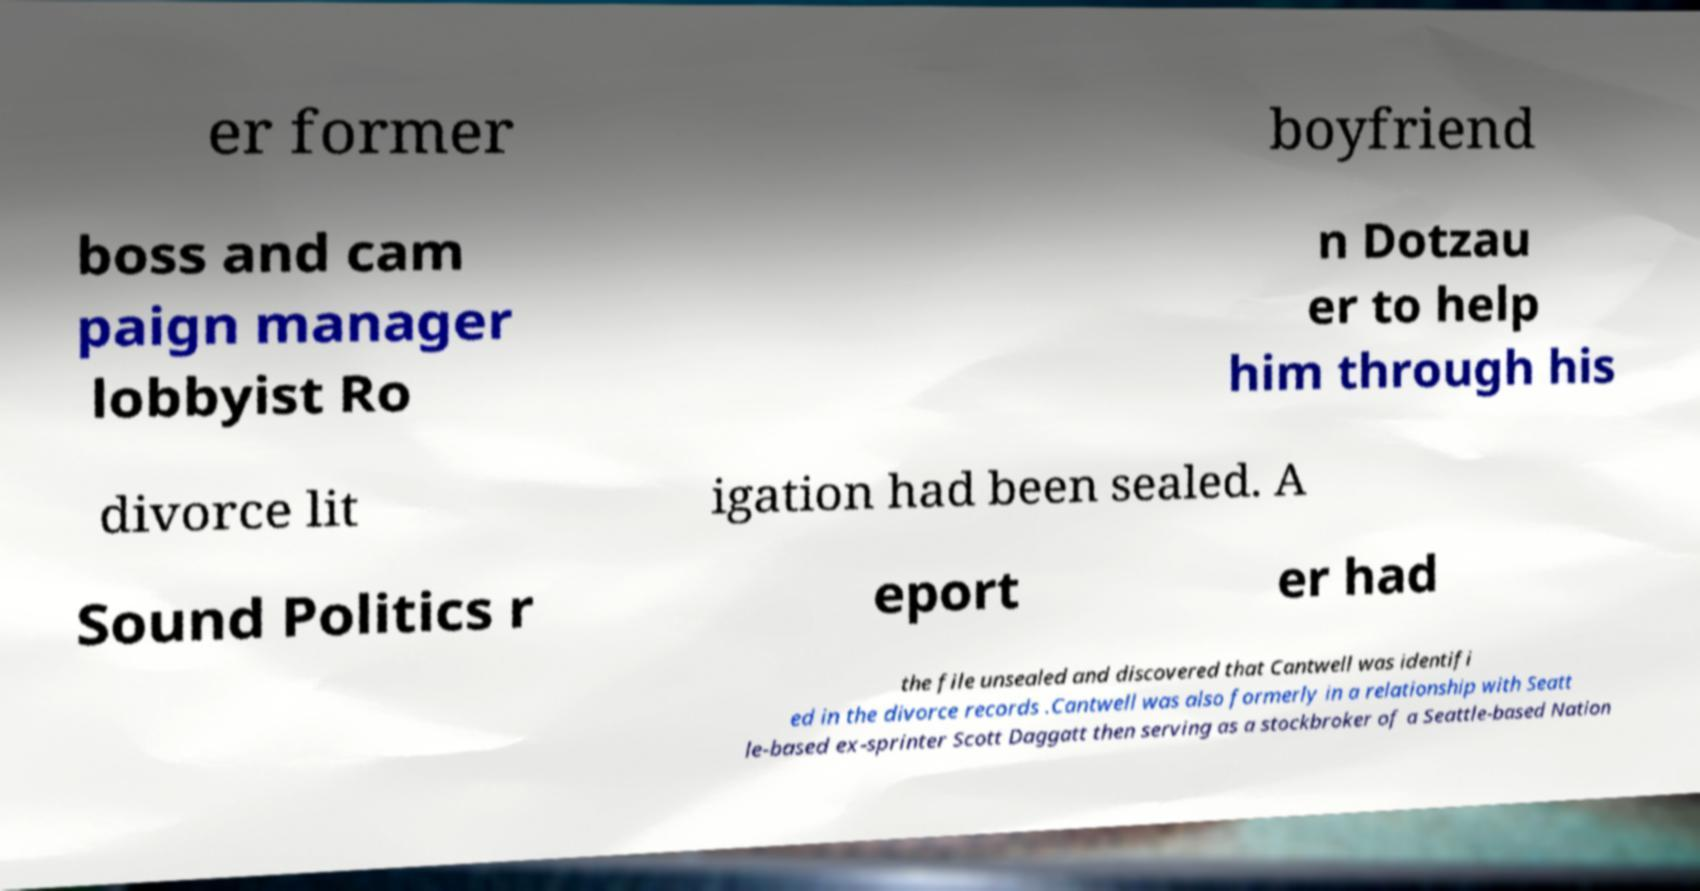There's text embedded in this image that I need extracted. Can you transcribe it verbatim? er former boyfriend boss and cam paign manager lobbyist Ro n Dotzau er to help him through his divorce lit igation had been sealed. A Sound Politics r eport er had the file unsealed and discovered that Cantwell was identifi ed in the divorce records .Cantwell was also formerly in a relationship with Seatt le-based ex-sprinter Scott Daggatt then serving as a stockbroker of a Seattle-based Nation 